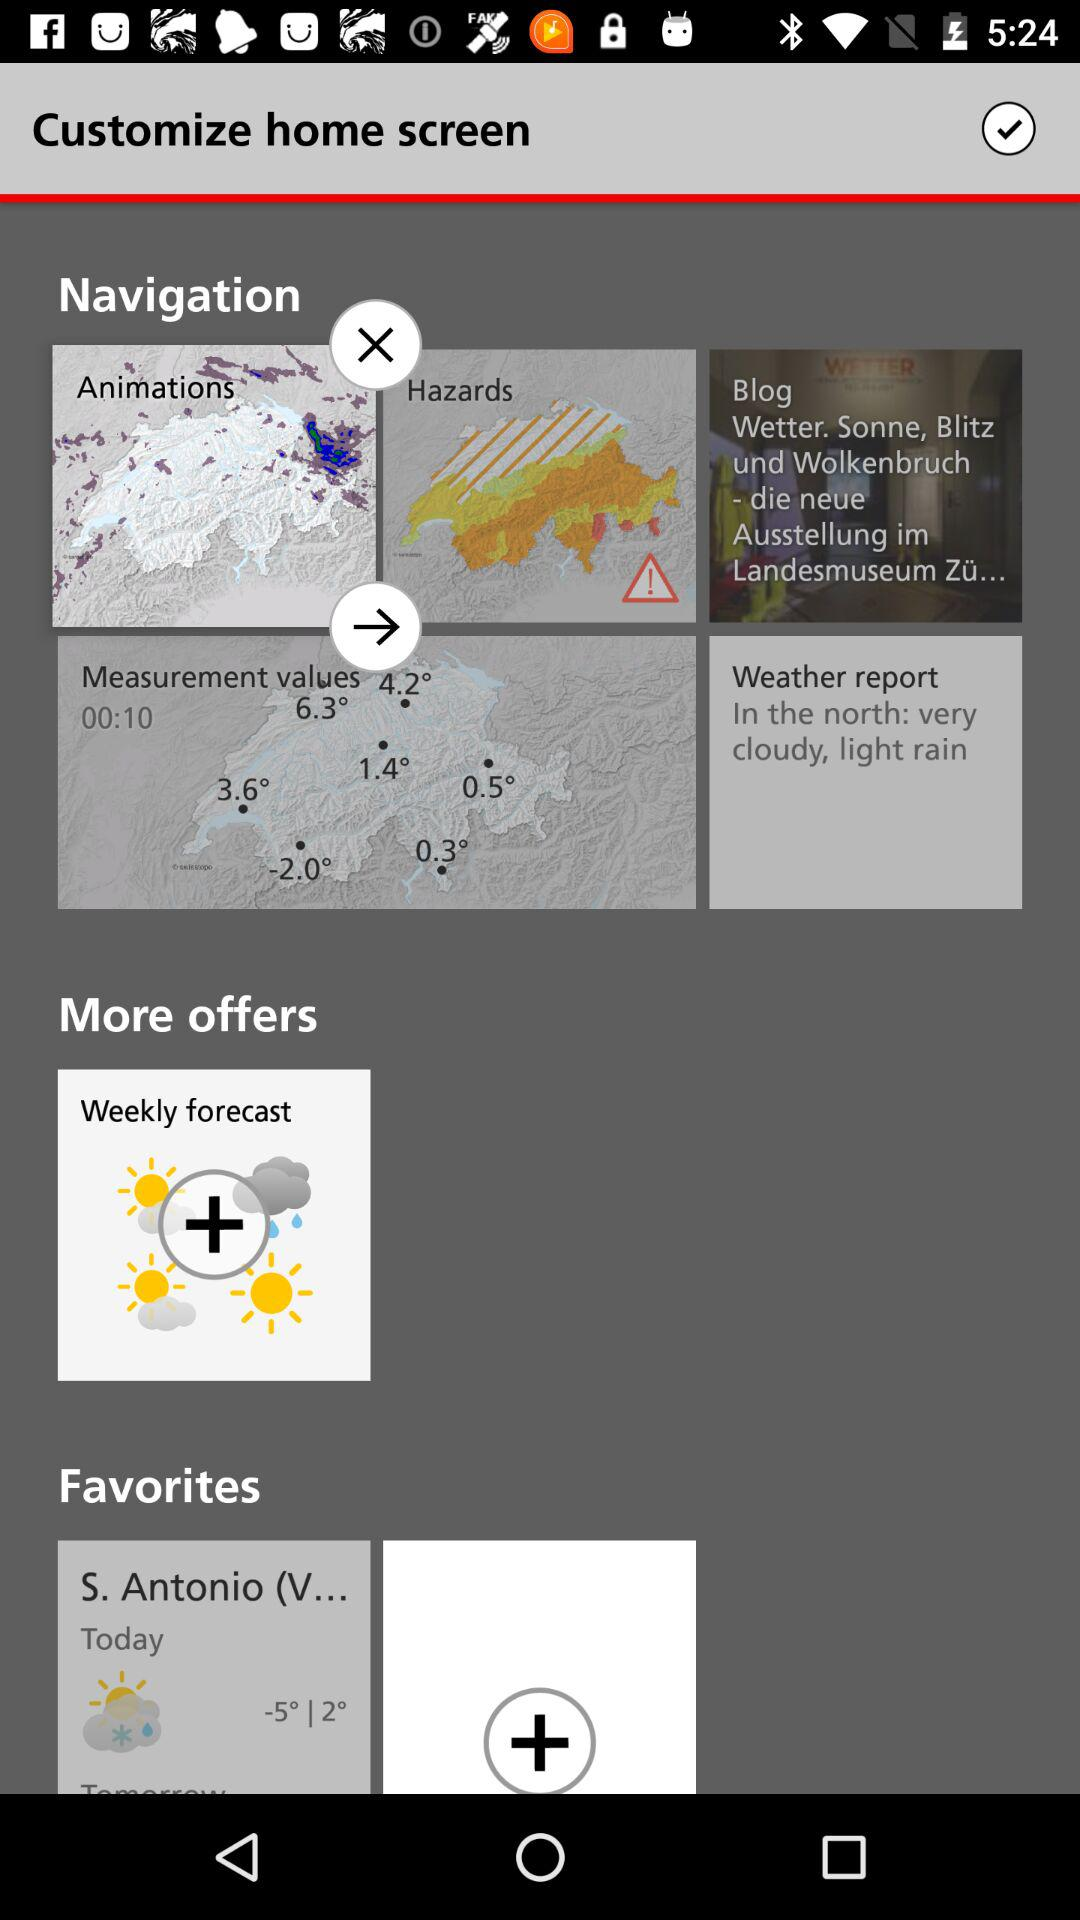How many items are on the home screen?
Answer the question using a single word or phrase. 3 